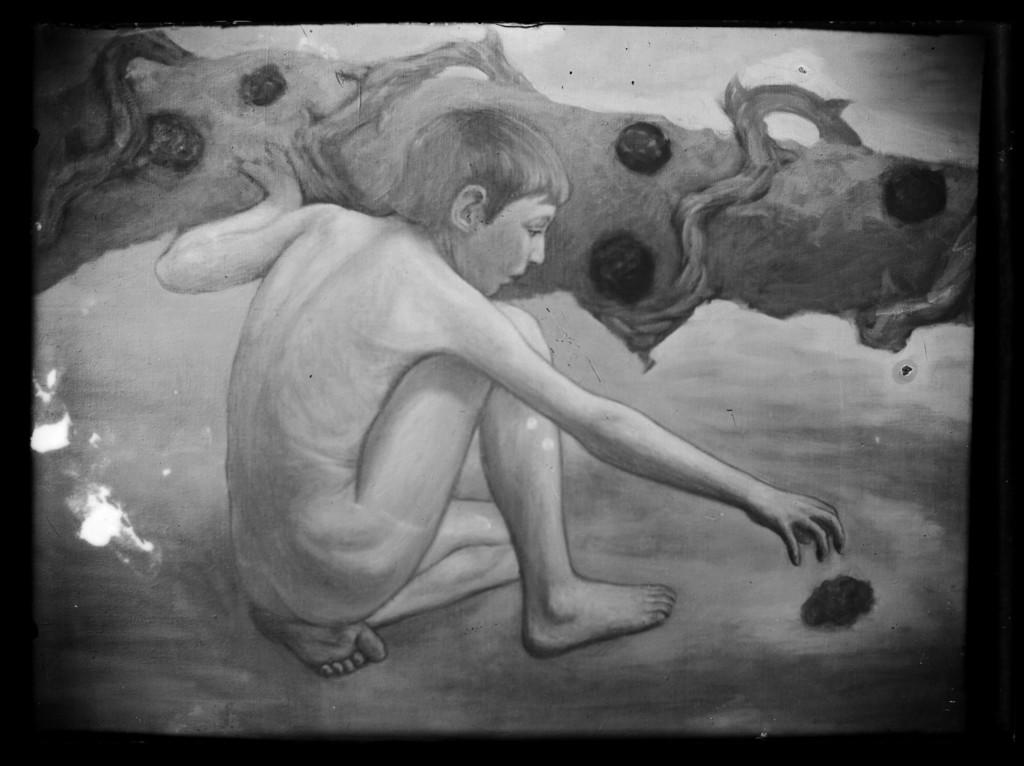What is the main subject of the image? There is an art piece in the image. What does the art piece depict? The art piece depicts a person. What is the color scheme of the image? The image is in black and white. What can be seen in the background of the image? There are objects visible in the background of the image. What type of apparel is the person wearing in the image? There is no apparel visible in the image, as it is in black and white and only depicts the outline of a person. Can you see any veins in the person's body in the image? There are no visible veins in the person's body in the image, as it is in black and white and only depicts the outline of a person. 